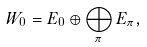Convert formula to latex. <formula><loc_0><loc_0><loc_500><loc_500>W _ { 0 } = E _ { 0 } \oplus \bigoplus _ { \pi } E _ { \pi } ,</formula> 